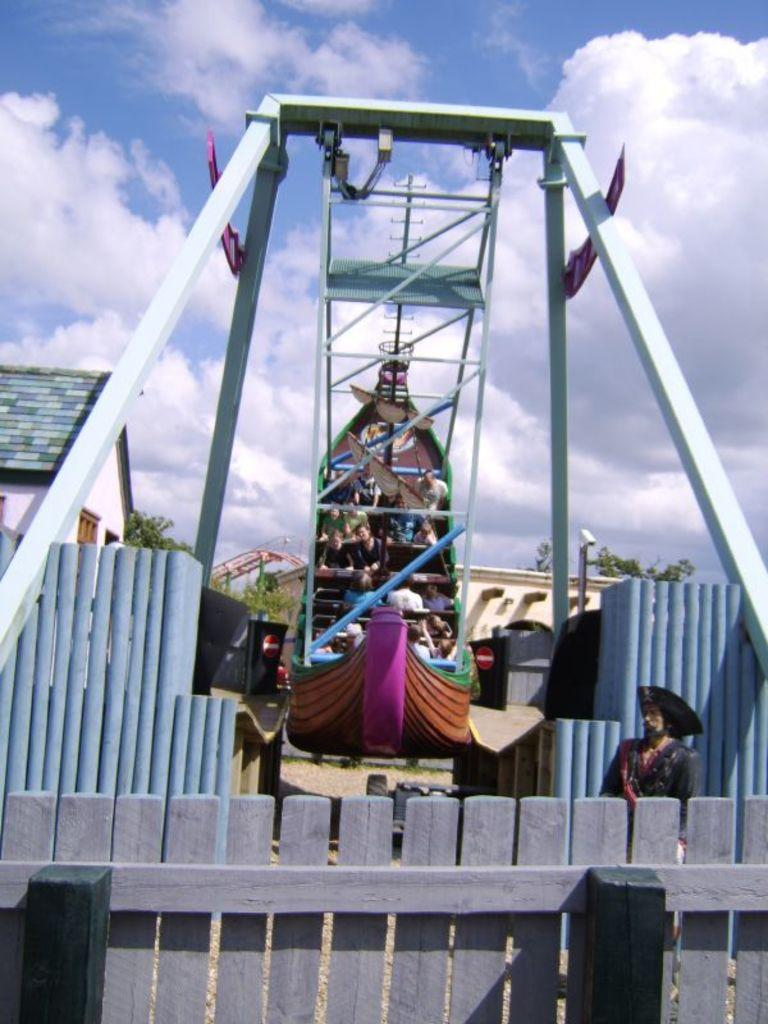What is happening in the image? There are people in an amusement park ride. What can be seen in the sky? There are clouds in the sky. What type of barrier is visible in the image? There is a wooden fence visible in the image. What nation is represented by the flag on the amusement park ride? There is no flag visible on the amusement park ride in the image. 